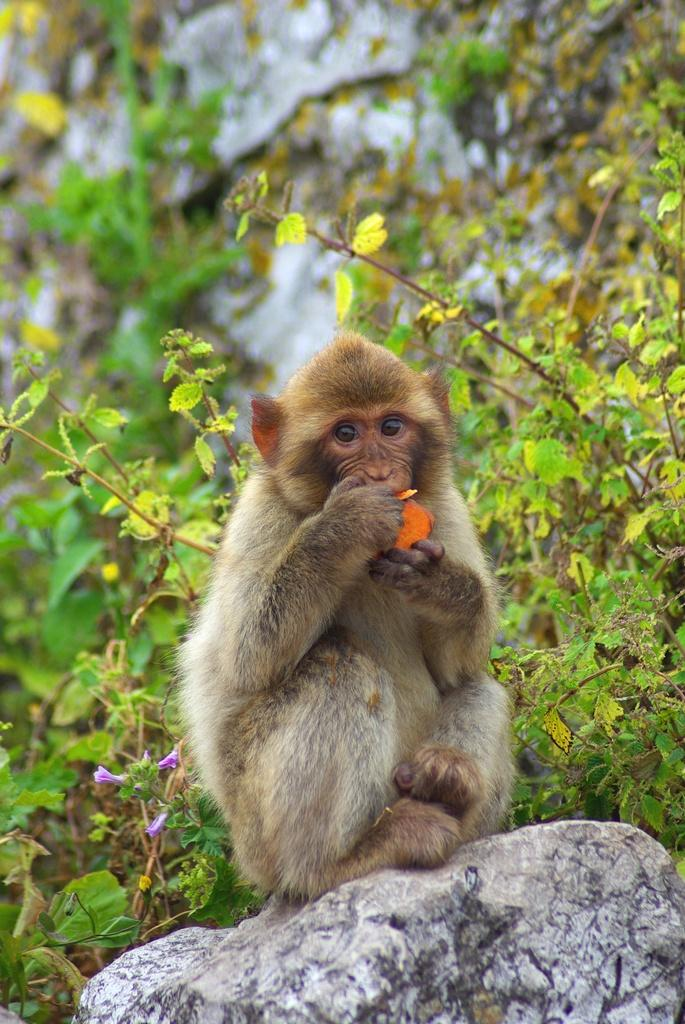Where was the image taken? The image was taken outside. What is in the foreground of the image? There is a monkey in the foreground of the image. What is the monkey doing in the image? The monkey is sitting on a rock and eating food. What can be seen in the background of the image? There are plants and rocks in the background of the image. What type of advertisement can be seen in the image? There is no advertisement present in the image; it features a monkey sitting on a rock and eating food outside. 